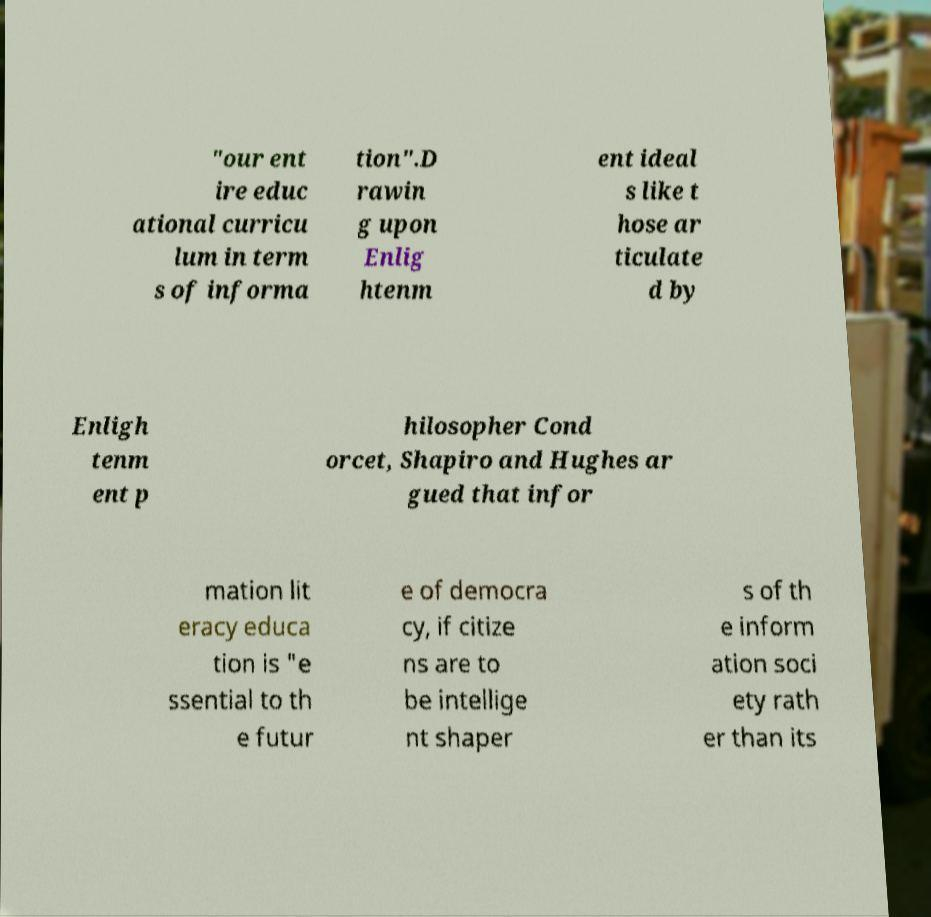There's text embedded in this image that I need extracted. Can you transcribe it verbatim? "our ent ire educ ational curricu lum in term s of informa tion".D rawin g upon Enlig htenm ent ideal s like t hose ar ticulate d by Enligh tenm ent p hilosopher Cond orcet, Shapiro and Hughes ar gued that infor mation lit eracy educa tion is "e ssential to th e futur e of democra cy, if citize ns are to be intellige nt shaper s of th e inform ation soci ety rath er than its 